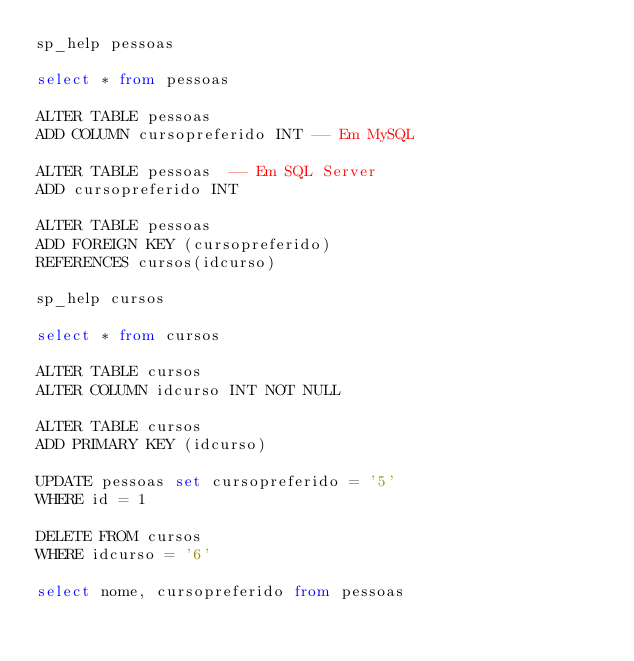Convert code to text. <code><loc_0><loc_0><loc_500><loc_500><_SQL_>sp_help pessoas

select * from pessoas

ALTER TABLE pessoas 
ADD COLUMN cursopreferido INT -- Em MySQL

ALTER TABLE pessoas  -- Em SQL Server
ADD cursopreferido INT

ALTER TABLE pessoas
ADD FOREIGN KEY (cursopreferido)
REFERENCES cursos(idcurso)

sp_help cursos
 
select * from cursos

ALTER TABLE cursos 
ALTER COLUMN idcurso INT NOT NULL  

ALTER TABLE cursos
ADD PRIMARY KEY (idcurso)

UPDATE pessoas set cursopreferido = '5'
WHERE id = 1

DELETE FROM cursos 
WHERE idcurso = '6'

select nome, cursopreferido from pessoas</code> 